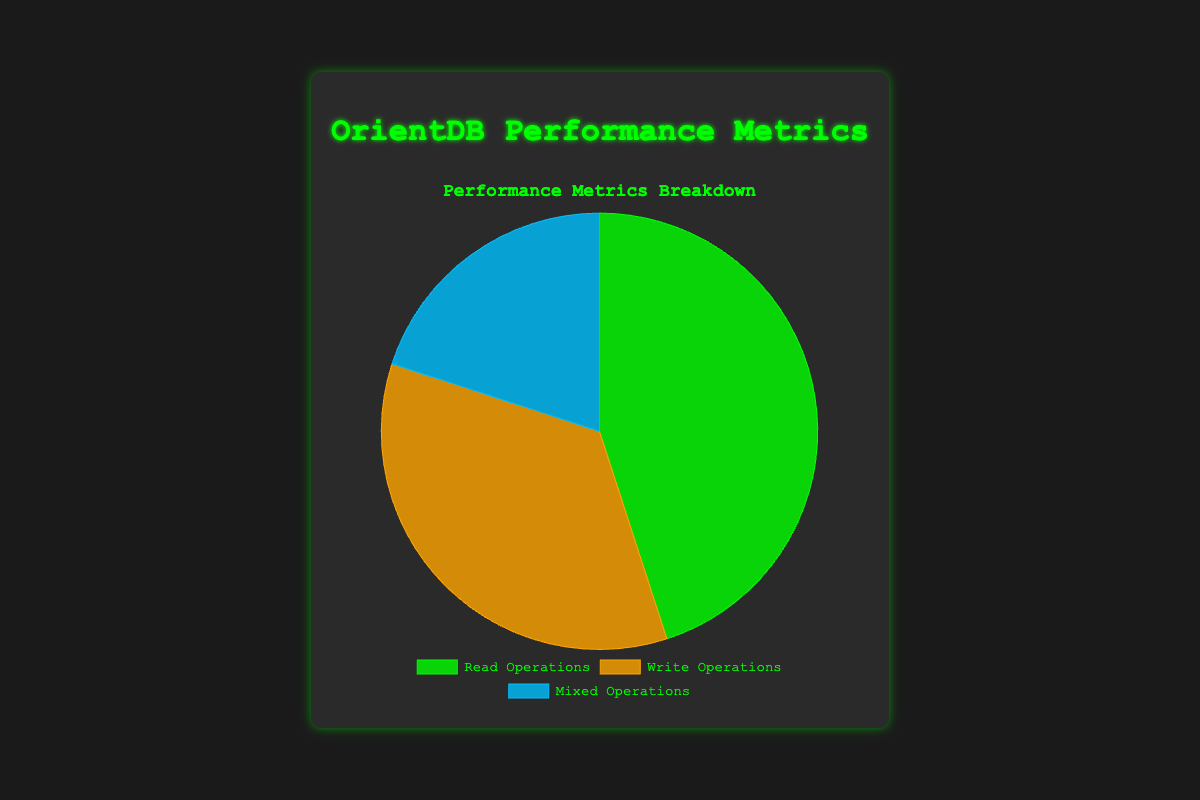What is the percentage of Read Operations in the dataset? To find the percentage of Read Operations, divide the count of Read Operations by the total count of all operations, then multiply by 100. The formula is (45 / (45 + 35 + 20)) * 100. This yields (45 / 100) * 100 = 45%.
Answer: 45% Which type of operation has the least data points? From the chart, Read Operations have 45 data points, Write Operations have 35 data points, and Mixed Operations have 20 data points. Mixed Operations have the least data points.
Answer: Mixed Operations How much more frequent are Read Operations compared to Mixed Operations? Subtract the number of Mixed Operations from the number of Read Operations. This calculation is 45 - 20 = 25. So, Read Operations are 25 data points more frequent than Mixed Operations.
Answer: 25 What's the ratio of Write Operations to the total number of operations? Divide the number of Write Operations by the total number of operations. This is calculated as 35 / (45 + 35 + 20) = 35 / 100 = 0.35, or 35%.
Answer: 0.35 If Mixed Operations increased by 10 points, what would be the new percentage of Mixed Operations? First, calculate the new total number of operations: 45 + 35 + (20 + 10) = 110. Then, find the new percentage of Mixed Operations: (30 / 110) * 100. This equals 27.27%.
Answer: 27.27% Which operation type has the closest number of data points to Write Operations? From the chart, Read Operations have 45 data points, Write Operations have 35, and Mixed Operations have 20. Read Operations are closer to Write Operations than Mixed Operations, with a difference of 10 points.
Answer: Read Operations Arrange the operations by their data points in descending order. Listing the operation types by their data points in descending order, we have: Read Operations (45), Write Operations (35), Mixed Operations (20).
Answer: Read Operations, Write Operations, Mixed Operations 